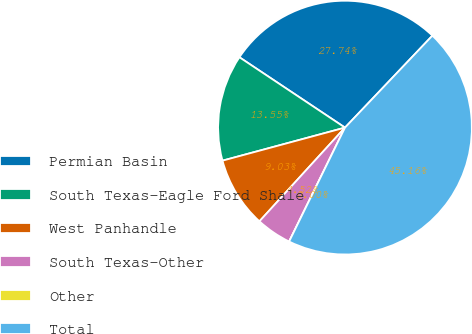<chart> <loc_0><loc_0><loc_500><loc_500><pie_chart><fcel>Permian Basin<fcel>South Texas-Eagle Ford Shale<fcel>West Panhandle<fcel>South Texas-Other<fcel>Other<fcel>Total<nl><fcel>27.74%<fcel>13.55%<fcel>9.03%<fcel>4.52%<fcel>0.0%<fcel>45.16%<nl></chart> 